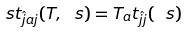Convert formula to latex. <formula><loc_0><loc_0><loc_500><loc_500>\ s t _ { \hat { j } a j } ( T , \ s ) = T _ { a } t _ { \hat { j } j } ( \ s )</formula> 